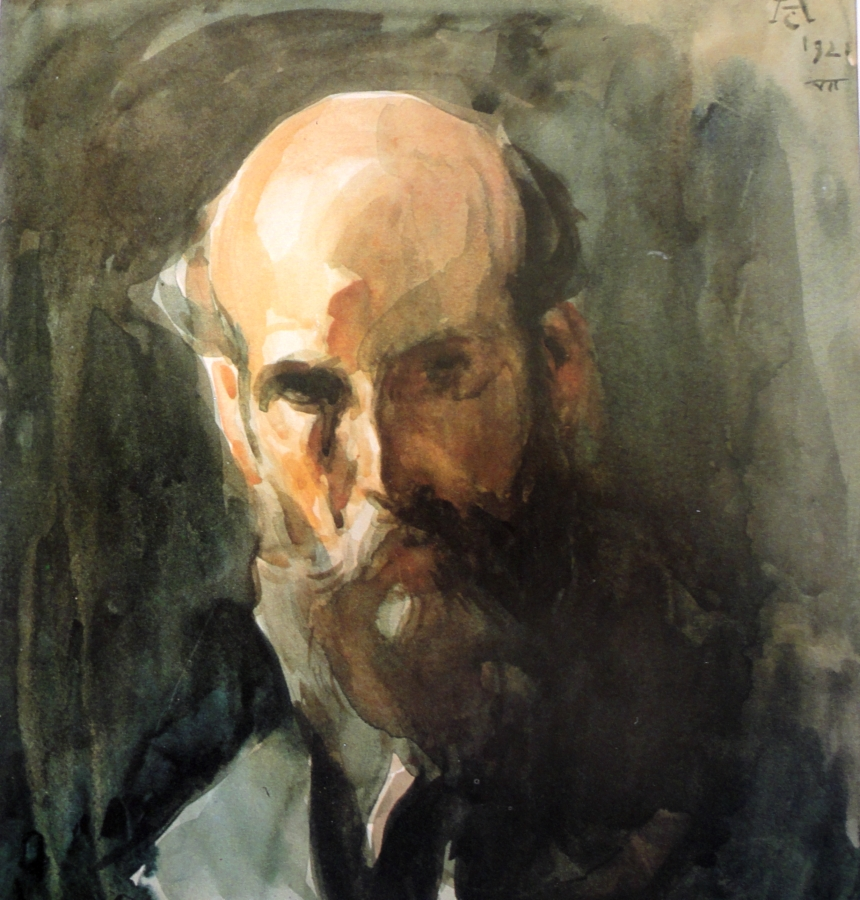What is the emotion conveyed by this painting? The painting conveys a somber and contemplative mood. The earthy tones combined with the indistinct background suggest introspection or melancholy. The man's partly obscured face further adds a layer of mystery and depth, evoking a sense of solitude and pensiveness. 